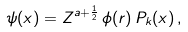Convert formula to latex. <formula><loc_0><loc_0><loc_500><loc_500>\psi ( x ) = Z ^ { a + \frac { 1 } { 2 } } \, \phi ( r ) \, P _ { k } ( x ) \, ,</formula> 